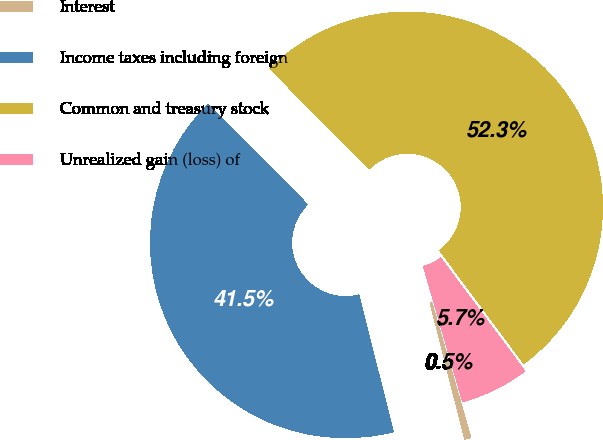Convert chart to OTSL. <chart><loc_0><loc_0><loc_500><loc_500><pie_chart><fcel>Interest<fcel>Income taxes including foreign<fcel>Common and treasury stock<fcel>Unrealized gain (loss) of<nl><fcel>0.53%<fcel>41.49%<fcel>52.28%<fcel>5.7%<nl></chart> 